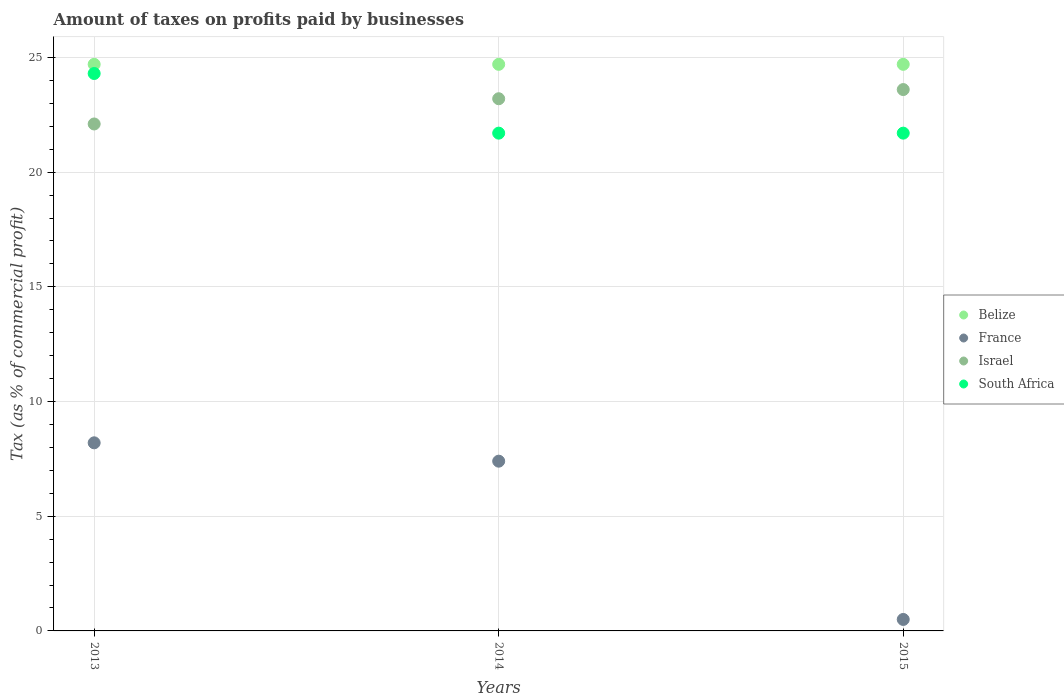How many different coloured dotlines are there?
Keep it short and to the point. 4. What is the percentage of taxes paid by businesses in South Africa in 2015?
Offer a terse response. 21.7. Across all years, what is the maximum percentage of taxes paid by businesses in Belize?
Make the answer very short. 24.7. Across all years, what is the minimum percentage of taxes paid by businesses in Belize?
Your answer should be compact. 24.7. In which year was the percentage of taxes paid by businesses in South Africa maximum?
Your response must be concise. 2013. In which year was the percentage of taxes paid by businesses in Belize minimum?
Give a very brief answer. 2013. What is the total percentage of taxes paid by businesses in South Africa in the graph?
Ensure brevity in your answer.  67.7. What is the difference between the percentage of taxes paid by businesses in Belize in 2013 and that in 2014?
Offer a very short reply. 0. What is the difference between the percentage of taxes paid by businesses in Israel in 2013 and the percentage of taxes paid by businesses in France in 2014?
Give a very brief answer. 14.7. What is the average percentage of taxes paid by businesses in Belize per year?
Offer a terse response. 24.7. In the year 2014, what is the difference between the percentage of taxes paid by businesses in South Africa and percentage of taxes paid by businesses in Belize?
Ensure brevity in your answer.  -3. In how many years, is the percentage of taxes paid by businesses in Belize greater than 16 %?
Make the answer very short. 3. Is the difference between the percentage of taxes paid by businesses in South Africa in 2013 and 2015 greater than the difference between the percentage of taxes paid by businesses in Belize in 2013 and 2015?
Offer a terse response. Yes. What is the difference between the highest and the second highest percentage of taxes paid by businesses in South Africa?
Your response must be concise. 2.6. What is the difference between the highest and the lowest percentage of taxes paid by businesses in South Africa?
Provide a short and direct response. 2.6. Is the percentage of taxes paid by businesses in South Africa strictly greater than the percentage of taxes paid by businesses in Belize over the years?
Provide a short and direct response. No. How many years are there in the graph?
Provide a short and direct response. 3. What is the difference between two consecutive major ticks on the Y-axis?
Your answer should be compact. 5. Does the graph contain any zero values?
Keep it short and to the point. No. Where does the legend appear in the graph?
Give a very brief answer. Center right. How many legend labels are there?
Provide a short and direct response. 4. What is the title of the graph?
Offer a terse response. Amount of taxes on profits paid by businesses. Does "Least developed countries" appear as one of the legend labels in the graph?
Make the answer very short. No. What is the label or title of the X-axis?
Make the answer very short. Years. What is the label or title of the Y-axis?
Keep it short and to the point. Tax (as % of commercial profit). What is the Tax (as % of commercial profit) of Belize in 2013?
Give a very brief answer. 24.7. What is the Tax (as % of commercial profit) in Israel in 2013?
Offer a terse response. 22.1. What is the Tax (as % of commercial profit) in South Africa in 2013?
Your response must be concise. 24.3. What is the Tax (as % of commercial profit) in Belize in 2014?
Keep it short and to the point. 24.7. What is the Tax (as % of commercial profit) of Israel in 2014?
Offer a very short reply. 23.2. What is the Tax (as % of commercial profit) in South Africa in 2014?
Keep it short and to the point. 21.7. What is the Tax (as % of commercial profit) of Belize in 2015?
Give a very brief answer. 24.7. What is the Tax (as % of commercial profit) in France in 2015?
Provide a succinct answer. 0.5. What is the Tax (as % of commercial profit) in Israel in 2015?
Provide a succinct answer. 23.6. What is the Tax (as % of commercial profit) in South Africa in 2015?
Provide a short and direct response. 21.7. Across all years, what is the maximum Tax (as % of commercial profit) of Belize?
Your answer should be very brief. 24.7. Across all years, what is the maximum Tax (as % of commercial profit) in Israel?
Your answer should be very brief. 23.6. Across all years, what is the maximum Tax (as % of commercial profit) of South Africa?
Provide a short and direct response. 24.3. Across all years, what is the minimum Tax (as % of commercial profit) in Belize?
Your answer should be compact. 24.7. Across all years, what is the minimum Tax (as % of commercial profit) of Israel?
Give a very brief answer. 22.1. Across all years, what is the minimum Tax (as % of commercial profit) of South Africa?
Your answer should be very brief. 21.7. What is the total Tax (as % of commercial profit) in Belize in the graph?
Make the answer very short. 74.1. What is the total Tax (as % of commercial profit) of Israel in the graph?
Make the answer very short. 68.9. What is the total Tax (as % of commercial profit) of South Africa in the graph?
Your response must be concise. 67.7. What is the difference between the Tax (as % of commercial profit) of Belize in 2013 and that in 2014?
Provide a succinct answer. 0. What is the difference between the Tax (as % of commercial profit) in Israel in 2013 and that in 2014?
Make the answer very short. -1.1. What is the difference between the Tax (as % of commercial profit) in South Africa in 2013 and that in 2014?
Offer a very short reply. 2.6. What is the difference between the Tax (as % of commercial profit) of Belize in 2013 and that in 2015?
Your answer should be compact. 0. What is the difference between the Tax (as % of commercial profit) in France in 2013 and that in 2015?
Make the answer very short. 7.7. What is the difference between the Tax (as % of commercial profit) in South Africa in 2013 and that in 2015?
Give a very brief answer. 2.6. What is the difference between the Tax (as % of commercial profit) in France in 2014 and that in 2015?
Offer a very short reply. 6.9. What is the difference between the Tax (as % of commercial profit) in Israel in 2014 and that in 2015?
Make the answer very short. -0.4. What is the difference between the Tax (as % of commercial profit) of Belize in 2013 and the Tax (as % of commercial profit) of Israel in 2014?
Make the answer very short. 1.5. What is the difference between the Tax (as % of commercial profit) of Israel in 2013 and the Tax (as % of commercial profit) of South Africa in 2014?
Make the answer very short. 0.4. What is the difference between the Tax (as % of commercial profit) of Belize in 2013 and the Tax (as % of commercial profit) of France in 2015?
Provide a succinct answer. 24.2. What is the difference between the Tax (as % of commercial profit) of France in 2013 and the Tax (as % of commercial profit) of Israel in 2015?
Give a very brief answer. -15.4. What is the difference between the Tax (as % of commercial profit) of Belize in 2014 and the Tax (as % of commercial profit) of France in 2015?
Make the answer very short. 24.2. What is the difference between the Tax (as % of commercial profit) in France in 2014 and the Tax (as % of commercial profit) in Israel in 2015?
Provide a short and direct response. -16.2. What is the difference between the Tax (as % of commercial profit) of France in 2014 and the Tax (as % of commercial profit) of South Africa in 2015?
Give a very brief answer. -14.3. What is the difference between the Tax (as % of commercial profit) in Israel in 2014 and the Tax (as % of commercial profit) in South Africa in 2015?
Provide a short and direct response. 1.5. What is the average Tax (as % of commercial profit) of Belize per year?
Provide a short and direct response. 24.7. What is the average Tax (as % of commercial profit) in France per year?
Provide a succinct answer. 5.37. What is the average Tax (as % of commercial profit) of Israel per year?
Your answer should be very brief. 22.97. What is the average Tax (as % of commercial profit) of South Africa per year?
Ensure brevity in your answer.  22.57. In the year 2013, what is the difference between the Tax (as % of commercial profit) of Belize and Tax (as % of commercial profit) of France?
Your answer should be very brief. 16.5. In the year 2013, what is the difference between the Tax (as % of commercial profit) in Belize and Tax (as % of commercial profit) in South Africa?
Offer a terse response. 0.4. In the year 2013, what is the difference between the Tax (as % of commercial profit) in France and Tax (as % of commercial profit) in Israel?
Offer a very short reply. -13.9. In the year 2013, what is the difference between the Tax (as % of commercial profit) in France and Tax (as % of commercial profit) in South Africa?
Your answer should be compact. -16.1. In the year 2013, what is the difference between the Tax (as % of commercial profit) in Israel and Tax (as % of commercial profit) in South Africa?
Keep it short and to the point. -2.2. In the year 2014, what is the difference between the Tax (as % of commercial profit) of France and Tax (as % of commercial profit) of Israel?
Your response must be concise. -15.8. In the year 2014, what is the difference between the Tax (as % of commercial profit) of France and Tax (as % of commercial profit) of South Africa?
Offer a very short reply. -14.3. In the year 2015, what is the difference between the Tax (as % of commercial profit) in Belize and Tax (as % of commercial profit) in France?
Ensure brevity in your answer.  24.2. In the year 2015, what is the difference between the Tax (as % of commercial profit) of France and Tax (as % of commercial profit) of Israel?
Make the answer very short. -23.1. In the year 2015, what is the difference between the Tax (as % of commercial profit) of France and Tax (as % of commercial profit) of South Africa?
Ensure brevity in your answer.  -21.2. What is the ratio of the Tax (as % of commercial profit) in France in 2013 to that in 2014?
Your response must be concise. 1.11. What is the ratio of the Tax (as % of commercial profit) of Israel in 2013 to that in 2014?
Your answer should be very brief. 0.95. What is the ratio of the Tax (as % of commercial profit) of South Africa in 2013 to that in 2014?
Your response must be concise. 1.12. What is the ratio of the Tax (as % of commercial profit) in Israel in 2013 to that in 2015?
Make the answer very short. 0.94. What is the ratio of the Tax (as % of commercial profit) of South Africa in 2013 to that in 2015?
Provide a short and direct response. 1.12. What is the ratio of the Tax (as % of commercial profit) in Israel in 2014 to that in 2015?
Give a very brief answer. 0.98. What is the difference between the highest and the second highest Tax (as % of commercial profit) of Belize?
Your answer should be very brief. 0. What is the difference between the highest and the second highest Tax (as % of commercial profit) of Israel?
Offer a very short reply. 0.4. What is the difference between the highest and the second highest Tax (as % of commercial profit) in South Africa?
Provide a short and direct response. 2.6. What is the difference between the highest and the lowest Tax (as % of commercial profit) in South Africa?
Ensure brevity in your answer.  2.6. 